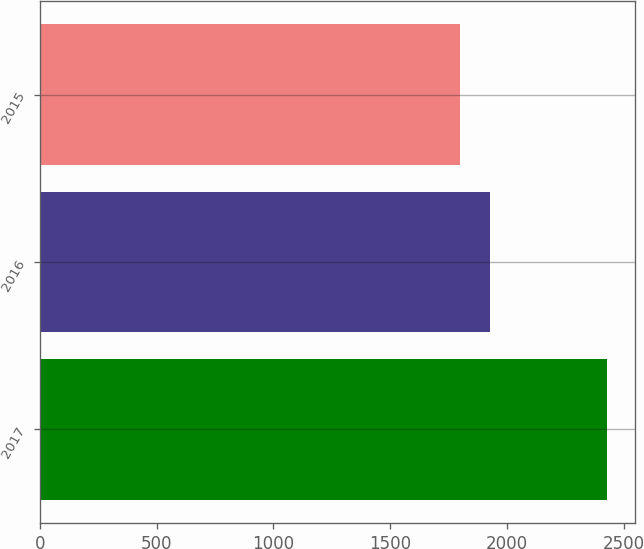<chart> <loc_0><loc_0><loc_500><loc_500><bar_chart><fcel>2017<fcel>2016<fcel>2015<nl><fcel>2426<fcel>1926<fcel>1798<nl></chart> 